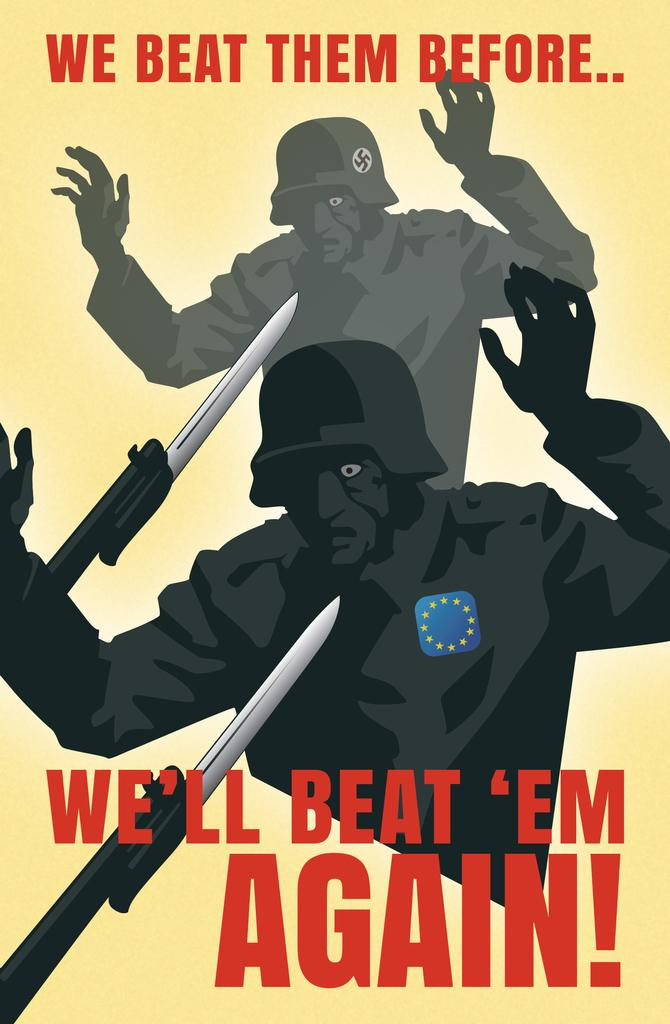What type of image is being described? The image is animated. Are there any words or letters in the image? Yes, there is text in the image. Can you describe the person depicted in the image? There is a depiction of a person in the image. What object is also shown in the image? There is a knife depicted in the image. Where is the bike stored in the image? There is no bike present in the image. What is the condition of the cellar in the image? There is no cellar present in the image. 